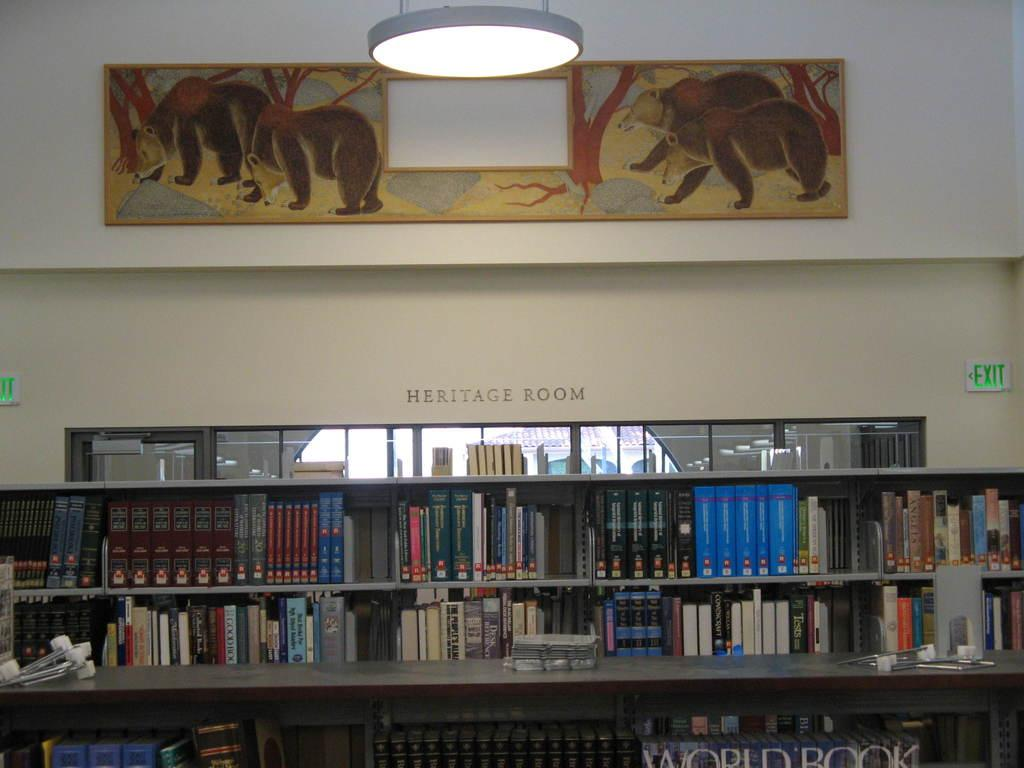<image>
Give a short and clear explanation of the subsequent image. The name given to this room with all the books is called the Heritage Room. 